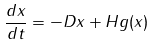Convert formula to latex. <formula><loc_0><loc_0><loc_500><loc_500>\frac { d x } { d t } = - D x + H g ( x )</formula> 